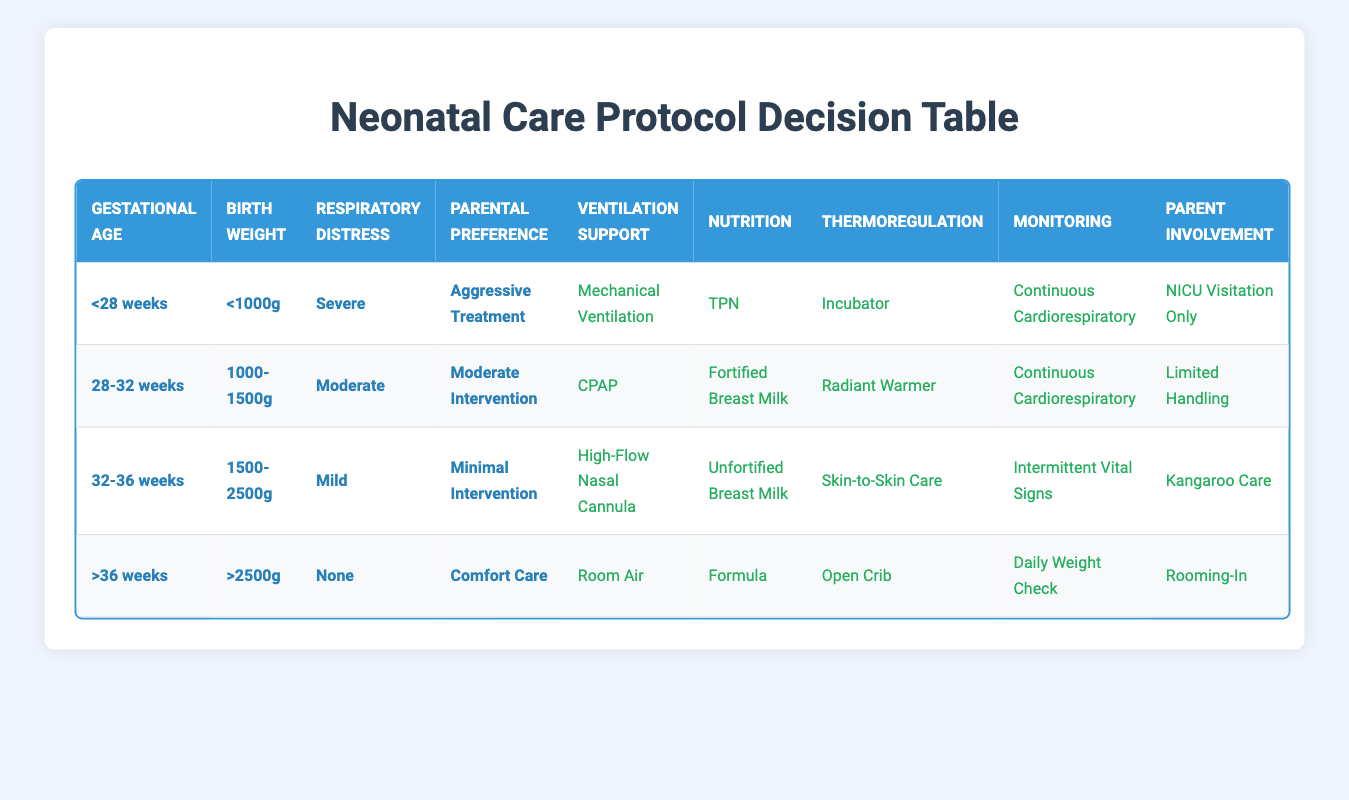What is the recommended Ventilation Support for infants born with a gestational age of less than 28 weeks? We look at the row for gestational age "<28 weeks". In this row, the recommended Ventilation Support is "Mechanical Ventilation".
Answer: Mechanical Ventilation For infants with a birth weight between 1000g and 1500g, what type of Nutrition is suggested? Looking at the row for birth weight "1000-1500g", we find that the suggested Nutrition is "Fortified Breast Milk".
Answer: Fortified Breast Milk Is skin-to-skin care recommended for any of the infants? To determine this, we need to check all rows for the action "Skin-to-Skin Care". It is found in the row for gestational age "32-36 weeks", birth weight "1500-2500g", and respiratory distress "Mild" under the option "Minimal Intervention", so the answer is yes.
Answer: Yes What type of monitoring is recommended for infants with no respiratory distress and over 36 weeks gestational age? In the row with gestational age ">36 weeks", birth weight ">2500g", and no respiratory distress, the recommended monitoring is "Daily Weight Check".
Answer: Daily Weight Check How many actions are suggested for infants with severe respiratory distress and aggressive treatment preference? For the conditions "<28 weeks", "<1000g", "Severe", and "Aggressive Treatment", we can refer to the corresponding row which lists 5 actions: "Mechanical Ventilation", "TPN", "Incubator", "Continuous Cardiorespiratory", and "NICU Visitation Only". Therefore, the total number of actions is 5.
Answer: 5 What is the only type of Parent Involvement suggested for infants receiving comfort care? In the row where the conditions are ">36 weeks", ">2500g", "None" for respiratory distress, and "Comfort Care", the only suggested type of Parent Involvement is "Rooming-In".
Answer: Rooming-In Do infants weighing less than 1000g ever receive high-flow nasal cannula treatment? We need to check the relevant rows where the weight is "<1000g". The only row matching this criterion is for gestational age "<28 weeks", which lists "Mechanical Ventilation" as the action for Ventilation Support. Since "High-Flow Nasal Cannula" does not appear in this context, the answer is no.
Answer: No What are the actions for infants aged 28-32 weeks and weighing between 1000g and 1500g who experience moderate respiratory distress? From the row with conditions "28-32 weeks", "1000-1500g", and "Moderate", we can see the actions are: "CPAP", "Fortified Breast Milk", "Radiant Warmer", "Continuous Cardiorespiratory", and "Limited Handling".
Answer: CPAP, Fortified Breast Milk, Radiant Warmer, Continuous Cardiorespiratory, Limited Handling What is the difference in parental involvement options between the infants less than 28 weeks and those greater than 36 weeks? For the "<28 weeks" and "Aggressive Treatment" group, the only parental involvement is "NICU Visitation Only". In contrast, the ">36 weeks" and "Comfort Care" group offers "Rooming-In". Therefore, the main difference is that one has more restricted involvement, while the other allows more involvement in care.
Answer: NICU Visitation Only vs. Rooming-In 